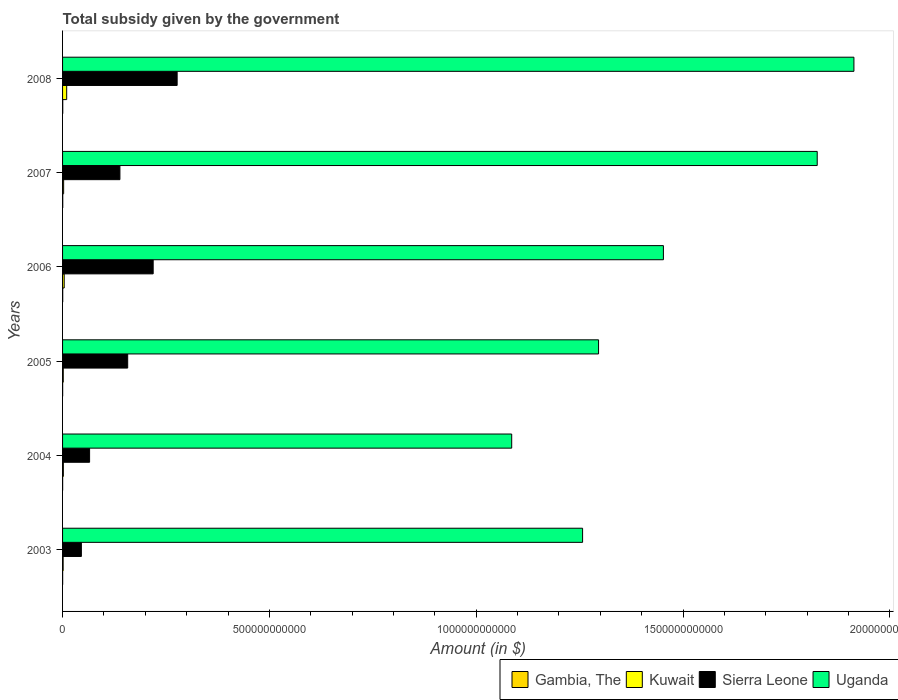How many different coloured bars are there?
Provide a short and direct response. 4. How many groups of bars are there?
Provide a short and direct response. 6. Are the number of bars on each tick of the Y-axis equal?
Keep it short and to the point. Yes. How many bars are there on the 1st tick from the bottom?
Provide a short and direct response. 4. What is the label of the 2nd group of bars from the top?
Offer a very short reply. 2007. What is the total revenue collected by the government in Uganda in 2007?
Keep it short and to the point. 1.82e+12. Across all years, what is the maximum total revenue collected by the government in Kuwait?
Provide a succinct answer. 9.98e+09. Across all years, what is the minimum total revenue collected by the government in Uganda?
Give a very brief answer. 1.09e+12. What is the total total revenue collected by the government in Gambia, The in the graph?
Your response must be concise. 1.90e+09. What is the difference between the total revenue collected by the government in Kuwait in 2005 and that in 2007?
Provide a succinct answer. -9.36e+08. What is the difference between the total revenue collected by the government in Kuwait in 2008 and the total revenue collected by the government in Sierra Leone in 2007?
Give a very brief answer. -1.29e+11. What is the average total revenue collected by the government in Kuwait per year?
Offer a terse response. 3.59e+09. In the year 2007, what is the difference between the total revenue collected by the government in Sierra Leone and total revenue collected by the government in Uganda?
Offer a terse response. -1.69e+12. What is the ratio of the total revenue collected by the government in Uganda in 2003 to that in 2007?
Offer a terse response. 0.69. What is the difference between the highest and the second highest total revenue collected by the government in Uganda?
Give a very brief answer. 8.87e+1. What is the difference between the highest and the lowest total revenue collected by the government in Sierra Leone?
Your answer should be compact. 2.32e+11. Is the sum of the total revenue collected by the government in Gambia, The in 2003 and 2007 greater than the maximum total revenue collected by the government in Sierra Leone across all years?
Provide a succinct answer. No. Is it the case that in every year, the sum of the total revenue collected by the government in Uganda and total revenue collected by the government in Gambia, The is greater than the sum of total revenue collected by the government in Sierra Leone and total revenue collected by the government in Kuwait?
Offer a terse response. No. What does the 4th bar from the top in 2008 represents?
Offer a very short reply. Gambia, The. What does the 3rd bar from the bottom in 2006 represents?
Offer a terse response. Sierra Leone. Is it the case that in every year, the sum of the total revenue collected by the government in Gambia, The and total revenue collected by the government in Kuwait is greater than the total revenue collected by the government in Uganda?
Your answer should be compact. No. How many bars are there?
Provide a short and direct response. 24. How many years are there in the graph?
Give a very brief answer. 6. What is the difference between two consecutive major ticks on the X-axis?
Ensure brevity in your answer.  5.00e+11. Are the values on the major ticks of X-axis written in scientific E-notation?
Your answer should be very brief. No. Does the graph contain any zero values?
Give a very brief answer. No. Does the graph contain grids?
Ensure brevity in your answer.  No. Where does the legend appear in the graph?
Ensure brevity in your answer.  Bottom right. How many legend labels are there?
Offer a terse response. 4. How are the legend labels stacked?
Your answer should be compact. Horizontal. What is the title of the graph?
Ensure brevity in your answer.  Total subsidy given by the government. Does "Greenland" appear as one of the legend labels in the graph?
Offer a very short reply. No. What is the label or title of the X-axis?
Make the answer very short. Amount (in $). What is the label or title of the Y-axis?
Your answer should be compact. Years. What is the Amount (in $) in Gambia, The in 2003?
Make the answer very short. 2.22e+08. What is the Amount (in $) of Kuwait in 2003?
Offer a very short reply. 1.40e+09. What is the Amount (in $) of Sierra Leone in 2003?
Make the answer very short. 4.55e+1. What is the Amount (in $) in Uganda in 2003?
Your response must be concise. 1.26e+12. What is the Amount (in $) of Gambia, The in 2004?
Provide a short and direct response. 1.91e+08. What is the Amount (in $) in Kuwait in 2004?
Give a very brief answer. 1.93e+09. What is the Amount (in $) of Sierra Leone in 2004?
Your answer should be compact. 6.53e+1. What is the Amount (in $) in Uganda in 2004?
Your answer should be very brief. 1.09e+12. What is the Amount (in $) in Gambia, The in 2005?
Offer a very short reply. 2.31e+08. What is the Amount (in $) in Kuwait in 2005?
Provide a short and direct response. 1.68e+09. What is the Amount (in $) in Sierra Leone in 2005?
Your answer should be compact. 1.57e+11. What is the Amount (in $) in Uganda in 2005?
Provide a succinct answer. 1.30e+12. What is the Amount (in $) of Gambia, The in 2006?
Offer a very short reply. 3.56e+08. What is the Amount (in $) of Kuwait in 2006?
Your answer should be compact. 3.94e+09. What is the Amount (in $) of Sierra Leone in 2006?
Offer a very short reply. 2.19e+11. What is the Amount (in $) of Uganda in 2006?
Your response must be concise. 1.45e+12. What is the Amount (in $) in Gambia, The in 2007?
Make the answer very short. 4.34e+08. What is the Amount (in $) in Kuwait in 2007?
Make the answer very short. 2.61e+09. What is the Amount (in $) in Sierra Leone in 2007?
Give a very brief answer. 1.39e+11. What is the Amount (in $) in Uganda in 2007?
Provide a succinct answer. 1.82e+12. What is the Amount (in $) in Gambia, The in 2008?
Provide a succinct answer. 4.63e+08. What is the Amount (in $) of Kuwait in 2008?
Provide a short and direct response. 9.98e+09. What is the Amount (in $) of Sierra Leone in 2008?
Your answer should be compact. 2.77e+11. What is the Amount (in $) in Uganda in 2008?
Ensure brevity in your answer.  1.91e+12. Across all years, what is the maximum Amount (in $) of Gambia, The?
Your answer should be very brief. 4.63e+08. Across all years, what is the maximum Amount (in $) in Kuwait?
Ensure brevity in your answer.  9.98e+09. Across all years, what is the maximum Amount (in $) in Sierra Leone?
Offer a terse response. 2.77e+11. Across all years, what is the maximum Amount (in $) in Uganda?
Your answer should be very brief. 1.91e+12. Across all years, what is the minimum Amount (in $) in Gambia, The?
Provide a succinct answer. 1.91e+08. Across all years, what is the minimum Amount (in $) in Kuwait?
Your answer should be compact. 1.40e+09. Across all years, what is the minimum Amount (in $) of Sierra Leone?
Provide a succinct answer. 4.55e+1. Across all years, what is the minimum Amount (in $) of Uganda?
Your answer should be compact. 1.09e+12. What is the total Amount (in $) in Gambia, The in the graph?
Provide a short and direct response. 1.90e+09. What is the total Amount (in $) of Kuwait in the graph?
Offer a terse response. 2.15e+1. What is the total Amount (in $) in Sierra Leone in the graph?
Offer a very short reply. 9.03e+11. What is the total Amount (in $) of Uganda in the graph?
Provide a succinct answer. 8.83e+12. What is the difference between the Amount (in $) in Gambia, The in 2003 and that in 2004?
Offer a very short reply. 3.08e+07. What is the difference between the Amount (in $) of Kuwait in 2003 and that in 2004?
Your answer should be very brief. -5.31e+08. What is the difference between the Amount (in $) of Sierra Leone in 2003 and that in 2004?
Provide a succinct answer. -1.98e+1. What is the difference between the Amount (in $) of Uganda in 2003 and that in 2004?
Keep it short and to the point. 1.71e+11. What is the difference between the Amount (in $) in Gambia, The in 2003 and that in 2005?
Provide a succinct answer. -9.00e+06. What is the difference between the Amount (in $) in Kuwait in 2003 and that in 2005?
Your response must be concise. -2.82e+08. What is the difference between the Amount (in $) in Sierra Leone in 2003 and that in 2005?
Your response must be concise. -1.12e+11. What is the difference between the Amount (in $) of Uganda in 2003 and that in 2005?
Ensure brevity in your answer.  -3.86e+1. What is the difference between the Amount (in $) of Gambia, The in 2003 and that in 2006?
Ensure brevity in your answer.  -1.34e+08. What is the difference between the Amount (in $) in Kuwait in 2003 and that in 2006?
Give a very brief answer. -2.54e+09. What is the difference between the Amount (in $) of Sierra Leone in 2003 and that in 2006?
Keep it short and to the point. -1.74e+11. What is the difference between the Amount (in $) in Uganda in 2003 and that in 2006?
Your answer should be compact. -1.95e+11. What is the difference between the Amount (in $) of Gambia, The in 2003 and that in 2007?
Ensure brevity in your answer.  -2.13e+08. What is the difference between the Amount (in $) of Kuwait in 2003 and that in 2007?
Make the answer very short. -1.22e+09. What is the difference between the Amount (in $) in Sierra Leone in 2003 and that in 2007?
Give a very brief answer. -9.32e+1. What is the difference between the Amount (in $) in Uganda in 2003 and that in 2007?
Make the answer very short. -5.67e+11. What is the difference between the Amount (in $) of Gambia, The in 2003 and that in 2008?
Your answer should be very brief. -2.42e+08. What is the difference between the Amount (in $) in Kuwait in 2003 and that in 2008?
Ensure brevity in your answer.  -8.58e+09. What is the difference between the Amount (in $) of Sierra Leone in 2003 and that in 2008?
Your answer should be very brief. -2.32e+11. What is the difference between the Amount (in $) in Uganda in 2003 and that in 2008?
Your response must be concise. -6.56e+11. What is the difference between the Amount (in $) in Gambia, The in 2004 and that in 2005?
Offer a terse response. -3.98e+07. What is the difference between the Amount (in $) in Kuwait in 2004 and that in 2005?
Your answer should be very brief. 2.49e+08. What is the difference between the Amount (in $) in Sierra Leone in 2004 and that in 2005?
Your response must be concise. -9.21e+1. What is the difference between the Amount (in $) in Uganda in 2004 and that in 2005?
Give a very brief answer. -2.10e+11. What is the difference between the Amount (in $) in Gambia, The in 2004 and that in 2006?
Give a very brief answer. -1.65e+08. What is the difference between the Amount (in $) in Kuwait in 2004 and that in 2006?
Give a very brief answer. -2.01e+09. What is the difference between the Amount (in $) of Sierra Leone in 2004 and that in 2006?
Your answer should be very brief. -1.54e+11. What is the difference between the Amount (in $) of Uganda in 2004 and that in 2006?
Keep it short and to the point. -3.67e+11. What is the difference between the Amount (in $) in Gambia, The in 2004 and that in 2007?
Provide a succinct answer. -2.44e+08. What is the difference between the Amount (in $) of Kuwait in 2004 and that in 2007?
Ensure brevity in your answer.  -6.87e+08. What is the difference between the Amount (in $) in Sierra Leone in 2004 and that in 2007?
Your answer should be compact. -7.33e+1. What is the difference between the Amount (in $) in Uganda in 2004 and that in 2007?
Your answer should be very brief. -7.39e+11. What is the difference between the Amount (in $) in Gambia, The in 2004 and that in 2008?
Offer a terse response. -2.72e+08. What is the difference between the Amount (in $) of Kuwait in 2004 and that in 2008?
Your answer should be very brief. -8.05e+09. What is the difference between the Amount (in $) in Sierra Leone in 2004 and that in 2008?
Your answer should be very brief. -2.12e+11. What is the difference between the Amount (in $) of Uganda in 2004 and that in 2008?
Your response must be concise. -8.27e+11. What is the difference between the Amount (in $) in Gambia, The in 2005 and that in 2006?
Give a very brief answer. -1.26e+08. What is the difference between the Amount (in $) of Kuwait in 2005 and that in 2006?
Give a very brief answer. -2.26e+09. What is the difference between the Amount (in $) in Sierra Leone in 2005 and that in 2006?
Offer a terse response. -6.16e+1. What is the difference between the Amount (in $) of Uganda in 2005 and that in 2006?
Provide a succinct answer. -1.57e+11. What is the difference between the Amount (in $) of Gambia, The in 2005 and that in 2007?
Your answer should be very brief. -2.04e+08. What is the difference between the Amount (in $) of Kuwait in 2005 and that in 2007?
Offer a very short reply. -9.36e+08. What is the difference between the Amount (in $) in Sierra Leone in 2005 and that in 2007?
Ensure brevity in your answer.  1.88e+1. What is the difference between the Amount (in $) of Uganda in 2005 and that in 2007?
Keep it short and to the point. -5.29e+11. What is the difference between the Amount (in $) of Gambia, The in 2005 and that in 2008?
Provide a succinct answer. -2.33e+08. What is the difference between the Amount (in $) in Kuwait in 2005 and that in 2008?
Offer a terse response. -8.30e+09. What is the difference between the Amount (in $) in Sierra Leone in 2005 and that in 2008?
Your response must be concise. -1.20e+11. What is the difference between the Amount (in $) of Uganda in 2005 and that in 2008?
Make the answer very short. -6.17e+11. What is the difference between the Amount (in $) in Gambia, The in 2006 and that in 2007?
Keep it short and to the point. -7.82e+07. What is the difference between the Amount (in $) in Kuwait in 2006 and that in 2007?
Provide a short and direct response. 1.33e+09. What is the difference between the Amount (in $) of Sierra Leone in 2006 and that in 2007?
Keep it short and to the point. 8.04e+1. What is the difference between the Amount (in $) in Uganda in 2006 and that in 2007?
Your answer should be compact. -3.72e+11. What is the difference between the Amount (in $) of Gambia, The in 2006 and that in 2008?
Your response must be concise. -1.07e+08. What is the difference between the Amount (in $) in Kuwait in 2006 and that in 2008?
Make the answer very short. -6.04e+09. What is the difference between the Amount (in $) of Sierra Leone in 2006 and that in 2008?
Give a very brief answer. -5.80e+1. What is the difference between the Amount (in $) in Uganda in 2006 and that in 2008?
Offer a terse response. -4.61e+11. What is the difference between the Amount (in $) in Gambia, The in 2007 and that in 2008?
Your response must be concise. -2.89e+07. What is the difference between the Amount (in $) of Kuwait in 2007 and that in 2008?
Your answer should be very brief. -7.36e+09. What is the difference between the Amount (in $) of Sierra Leone in 2007 and that in 2008?
Provide a short and direct response. -1.38e+11. What is the difference between the Amount (in $) of Uganda in 2007 and that in 2008?
Keep it short and to the point. -8.87e+1. What is the difference between the Amount (in $) in Gambia, The in 2003 and the Amount (in $) in Kuwait in 2004?
Give a very brief answer. -1.71e+09. What is the difference between the Amount (in $) of Gambia, The in 2003 and the Amount (in $) of Sierra Leone in 2004?
Offer a terse response. -6.51e+1. What is the difference between the Amount (in $) of Gambia, The in 2003 and the Amount (in $) of Uganda in 2004?
Give a very brief answer. -1.09e+12. What is the difference between the Amount (in $) of Kuwait in 2003 and the Amount (in $) of Sierra Leone in 2004?
Provide a short and direct response. -6.39e+1. What is the difference between the Amount (in $) in Kuwait in 2003 and the Amount (in $) in Uganda in 2004?
Your response must be concise. -1.08e+12. What is the difference between the Amount (in $) of Sierra Leone in 2003 and the Amount (in $) of Uganda in 2004?
Your answer should be very brief. -1.04e+12. What is the difference between the Amount (in $) in Gambia, The in 2003 and the Amount (in $) in Kuwait in 2005?
Make the answer very short. -1.46e+09. What is the difference between the Amount (in $) of Gambia, The in 2003 and the Amount (in $) of Sierra Leone in 2005?
Your response must be concise. -1.57e+11. What is the difference between the Amount (in $) of Gambia, The in 2003 and the Amount (in $) of Uganda in 2005?
Make the answer very short. -1.30e+12. What is the difference between the Amount (in $) of Kuwait in 2003 and the Amount (in $) of Sierra Leone in 2005?
Your answer should be very brief. -1.56e+11. What is the difference between the Amount (in $) in Kuwait in 2003 and the Amount (in $) in Uganda in 2005?
Provide a succinct answer. -1.29e+12. What is the difference between the Amount (in $) of Sierra Leone in 2003 and the Amount (in $) of Uganda in 2005?
Ensure brevity in your answer.  -1.25e+12. What is the difference between the Amount (in $) in Gambia, The in 2003 and the Amount (in $) in Kuwait in 2006?
Offer a very short reply. -3.72e+09. What is the difference between the Amount (in $) in Gambia, The in 2003 and the Amount (in $) in Sierra Leone in 2006?
Your response must be concise. -2.19e+11. What is the difference between the Amount (in $) in Gambia, The in 2003 and the Amount (in $) in Uganda in 2006?
Ensure brevity in your answer.  -1.45e+12. What is the difference between the Amount (in $) of Kuwait in 2003 and the Amount (in $) of Sierra Leone in 2006?
Ensure brevity in your answer.  -2.18e+11. What is the difference between the Amount (in $) of Kuwait in 2003 and the Amount (in $) of Uganda in 2006?
Offer a terse response. -1.45e+12. What is the difference between the Amount (in $) of Sierra Leone in 2003 and the Amount (in $) of Uganda in 2006?
Keep it short and to the point. -1.41e+12. What is the difference between the Amount (in $) of Gambia, The in 2003 and the Amount (in $) of Kuwait in 2007?
Offer a terse response. -2.39e+09. What is the difference between the Amount (in $) of Gambia, The in 2003 and the Amount (in $) of Sierra Leone in 2007?
Your answer should be very brief. -1.38e+11. What is the difference between the Amount (in $) of Gambia, The in 2003 and the Amount (in $) of Uganda in 2007?
Keep it short and to the point. -1.82e+12. What is the difference between the Amount (in $) in Kuwait in 2003 and the Amount (in $) in Sierra Leone in 2007?
Make the answer very short. -1.37e+11. What is the difference between the Amount (in $) in Kuwait in 2003 and the Amount (in $) in Uganda in 2007?
Provide a succinct answer. -1.82e+12. What is the difference between the Amount (in $) of Sierra Leone in 2003 and the Amount (in $) of Uganda in 2007?
Offer a terse response. -1.78e+12. What is the difference between the Amount (in $) of Gambia, The in 2003 and the Amount (in $) of Kuwait in 2008?
Provide a short and direct response. -9.76e+09. What is the difference between the Amount (in $) of Gambia, The in 2003 and the Amount (in $) of Sierra Leone in 2008?
Provide a succinct answer. -2.77e+11. What is the difference between the Amount (in $) in Gambia, The in 2003 and the Amount (in $) in Uganda in 2008?
Make the answer very short. -1.91e+12. What is the difference between the Amount (in $) in Kuwait in 2003 and the Amount (in $) in Sierra Leone in 2008?
Provide a short and direct response. -2.76e+11. What is the difference between the Amount (in $) of Kuwait in 2003 and the Amount (in $) of Uganda in 2008?
Offer a very short reply. -1.91e+12. What is the difference between the Amount (in $) in Sierra Leone in 2003 and the Amount (in $) in Uganda in 2008?
Ensure brevity in your answer.  -1.87e+12. What is the difference between the Amount (in $) of Gambia, The in 2004 and the Amount (in $) of Kuwait in 2005?
Provide a succinct answer. -1.49e+09. What is the difference between the Amount (in $) in Gambia, The in 2004 and the Amount (in $) in Sierra Leone in 2005?
Give a very brief answer. -1.57e+11. What is the difference between the Amount (in $) in Gambia, The in 2004 and the Amount (in $) in Uganda in 2005?
Make the answer very short. -1.30e+12. What is the difference between the Amount (in $) in Kuwait in 2004 and the Amount (in $) in Sierra Leone in 2005?
Give a very brief answer. -1.55e+11. What is the difference between the Amount (in $) in Kuwait in 2004 and the Amount (in $) in Uganda in 2005?
Offer a terse response. -1.29e+12. What is the difference between the Amount (in $) of Sierra Leone in 2004 and the Amount (in $) of Uganda in 2005?
Keep it short and to the point. -1.23e+12. What is the difference between the Amount (in $) of Gambia, The in 2004 and the Amount (in $) of Kuwait in 2006?
Provide a short and direct response. -3.75e+09. What is the difference between the Amount (in $) in Gambia, The in 2004 and the Amount (in $) in Sierra Leone in 2006?
Your answer should be compact. -2.19e+11. What is the difference between the Amount (in $) of Gambia, The in 2004 and the Amount (in $) of Uganda in 2006?
Your answer should be very brief. -1.45e+12. What is the difference between the Amount (in $) of Kuwait in 2004 and the Amount (in $) of Sierra Leone in 2006?
Provide a short and direct response. -2.17e+11. What is the difference between the Amount (in $) of Kuwait in 2004 and the Amount (in $) of Uganda in 2006?
Your answer should be very brief. -1.45e+12. What is the difference between the Amount (in $) of Sierra Leone in 2004 and the Amount (in $) of Uganda in 2006?
Provide a succinct answer. -1.39e+12. What is the difference between the Amount (in $) of Gambia, The in 2004 and the Amount (in $) of Kuwait in 2007?
Ensure brevity in your answer.  -2.42e+09. What is the difference between the Amount (in $) in Gambia, The in 2004 and the Amount (in $) in Sierra Leone in 2007?
Make the answer very short. -1.38e+11. What is the difference between the Amount (in $) of Gambia, The in 2004 and the Amount (in $) of Uganda in 2007?
Give a very brief answer. -1.82e+12. What is the difference between the Amount (in $) in Kuwait in 2004 and the Amount (in $) in Sierra Leone in 2007?
Keep it short and to the point. -1.37e+11. What is the difference between the Amount (in $) of Kuwait in 2004 and the Amount (in $) of Uganda in 2007?
Ensure brevity in your answer.  -1.82e+12. What is the difference between the Amount (in $) in Sierra Leone in 2004 and the Amount (in $) in Uganda in 2007?
Provide a succinct answer. -1.76e+12. What is the difference between the Amount (in $) in Gambia, The in 2004 and the Amount (in $) in Kuwait in 2008?
Provide a succinct answer. -9.79e+09. What is the difference between the Amount (in $) of Gambia, The in 2004 and the Amount (in $) of Sierra Leone in 2008?
Keep it short and to the point. -2.77e+11. What is the difference between the Amount (in $) in Gambia, The in 2004 and the Amount (in $) in Uganda in 2008?
Your answer should be compact. -1.91e+12. What is the difference between the Amount (in $) of Kuwait in 2004 and the Amount (in $) of Sierra Leone in 2008?
Keep it short and to the point. -2.75e+11. What is the difference between the Amount (in $) of Kuwait in 2004 and the Amount (in $) of Uganda in 2008?
Ensure brevity in your answer.  -1.91e+12. What is the difference between the Amount (in $) of Sierra Leone in 2004 and the Amount (in $) of Uganda in 2008?
Your answer should be compact. -1.85e+12. What is the difference between the Amount (in $) of Gambia, The in 2005 and the Amount (in $) of Kuwait in 2006?
Give a very brief answer. -3.71e+09. What is the difference between the Amount (in $) of Gambia, The in 2005 and the Amount (in $) of Sierra Leone in 2006?
Ensure brevity in your answer.  -2.19e+11. What is the difference between the Amount (in $) in Gambia, The in 2005 and the Amount (in $) in Uganda in 2006?
Give a very brief answer. -1.45e+12. What is the difference between the Amount (in $) of Kuwait in 2005 and the Amount (in $) of Sierra Leone in 2006?
Your answer should be compact. -2.17e+11. What is the difference between the Amount (in $) in Kuwait in 2005 and the Amount (in $) in Uganda in 2006?
Your response must be concise. -1.45e+12. What is the difference between the Amount (in $) of Sierra Leone in 2005 and the Amount (in $) of Uganda in 2006?
Your response must be concise. -1.30e+12. What is the difference between the Amount (in $) of Gambia, The in 2005 and the Amount (in $) of Kuwait in 2007?
Ensure brevity in your answer.  -2.38e+09. What is the difference between the Amount (in $) of Gambia, The in 2005 and the Amount (in $) of Sierra Leone in 2007?
Your answer should be very brief. -1.38e+11. What is the difference between the Amount (in $) of Gambia, The in 2005 and the Amount (in $) of Uganda in 2007?
Provide a succinct answer. -1.82e+12. What is the difference between the Amount (in $) in Kuwait in 2005 and the Amount (in $) in Sierra Leone in 2007?
Give a very brief answer. -1.37e+11. What is the difference between the Amount (in $) in Kuwait in 2005 and the Amount (in $) in Uganda in 2007?
Your response must be concise. -1.82e+12. What is the difference between the Amount (in $) of Sierra Leone in 2005 and the Amount (in $) of Uganda in 2007?
Your answer should be very brief. -1.67e+12. What is the difference between the Amount (in $) of Gambia, The in 2005 and the Amount (in $) of Kuwait in 2008?
Offer a very short reply. -9.75e+09. What is the difference between the Amount (in $) in Gambia, The in 2005 and the Amount (in $) in Sierra Leone in 2008?
Your response must be concise. -2.77e+11. What is the difference between the Amount (in $) of Gambia, The in 2005 and the Amount (in $) of Uganda in 2008?
Keep it short and to the point. -1.91e+12. What is the difference between the Amount (in $) of Kuwait in 2005 and the Amount (in $) of Sierra Leone in 2008?
Offer a very short reply. -2.75e+11. What is the difference between the Amount (in $) of Kuwait in 2005 and the Amount (in $) of Uganda in 2008?
Give a very brief answer. -1.91e+12. What is the difference between the Amount (in $) in Sierra Leone in 2005 and the Amount (in $) in Uganda in 2008?
Give a very brief answer. -1.76e+12. What is the difference between the Amount (in $) in Gambia, The in 2006 and the Amount (in $) in Kuwait in 2007?
Keep it short and to the point. -2.26e+09. What is the difference between the Amount (in $) of Gambia, The in 2006 and the Amount (in $) of Sierra Leone in 2007?
Offer a very short reply. -1.38e+11. What is the difference between the Amount (in $) in Gambia, The in 2006 and the Amount (in $) in Uganda in 2007?
Your response must be concise. -1.82e+12. What is the difference between the Amount (in $) of Kuwait in 2006 and the Amount (in $) of Sierra Leone in 2007?
Your answer should be very brief. -1.35e+11. What is the difference between the Amount (in $) of Kuwait in 2006 and the Amount (in $) of Uganda in 2007?
Make the answer very short. -1.82e+12. What is the difference between the Amount (in $) in Sierra Leone in 2006 and the Amount (in $) in Uganda in 2007?
Provide a succinct answer. -1.61e+12. What is the difference between the Amount (in $) in Gambia, The in 2006 and the Amount (in $) in Kuwait in 2008?
Ensure brevity in your answer.  -9.62e+09. What is the difference between the Amount (in $) in Gambia, The in 2006 and the Amount (in $) in Sierra Leone in 2008?
Provide a succinct answer. -2.77e+11. What is the difference between the Amount (in $) in Gambia, The in 2006 and the Amount (in $) in Uganda in 2008?
Offer a very short reply. -1.91e+12. What is the difference between the Amount (in $) in Kuwait in 2006 and the Amount (in $) in Sierra Leone in 2008?
Ensure brevity in your answer.  -2.73e+11. What is the difference between the Amount (in $) in Kuwait in 2006 and the Amount (in $) in Uganda in 2008?
Make the answer very short. -1.91e+12. What is the difference between the Amount (in $) in Sierra Leone in 2006 and the Amount (in $) in Uganda in 2008?
Keep it short and to the point. -1.69e+12. What is the difference between the Amount (in $) in Gambia, The in 2007 and the Amount (in $) in Kuwait in 2008?
Keep it short and to the point. -9.54e+09. What is the difference between the Amount (in $) in Gambia, The in 2007 and the Amount (in $) in Sierra Leone in 2008?
Your response must be concise. -2.77e+11. What is the difference between the Amount (in $) of Gambia, The in 2007 and the Amount (in $) of Uganda in 2008?
Offer a very short reply. -1.91e+12. What is the difference between the Amount (in $) in Kuwait in 2007 and the Amount (in $) in Sierra Leone in 2008?
Give a very brief answer. -2.74e+11. What is the difference between the Amount (in $) of Kuwait in 2007 and the Amount (in $) of Uganda in 2008?
Your answer should be very brief. -1.91e+12. What is the difference between the Amount (in $) in Sierra Leone in 2007 and the Amount (in $) in Uganda in 2008?
Provide a short and direct response. -1.77e+12. What is the average Amount (in $) of Gambia, The per year?
Make the answer very short. 3.16e+08. What is the average Amount (in $) in Kuwait per year?
Keep it short and to the point. 3.59e+09. What is the average Amount (in $) of Sierra Leone per year?
Provide a succinct answer. 1.50e+11. What is the average Amount (in $) of Uganda per year?
Offer a very short reply. 1.47e+12. In the year 2003, what is the difference between the Amount (in $) in Gambia, The and Amount (in $) in Kuwait?
Give a very brief answer. -1.17e+09. In the year 2003, what is the difference between the Amount (in $) in Gambia, The and Amount (in $) in Sierra Leone?
Keep it short and to the point. -4.53e+1. In the year 2003, what is the difference between the Amount (in $) of Gambia, The and Amount (in $) of Uganda?
Keep it short and to the point. -1.26e+12. In the year 2003, what is the difference between the Amount (in $) in Kuwait and Amount (in $) in Sierra Leone?
Provide a succinct answer. -4.41e+1. In the year 2003, what is the difference between the Amount (in $) in Kuwait and Amount (in $) in Uganda?
Provide a succinct answer. -1.26e+12. In the year 2003, what is the difference between the Amount (in $) in Sierra Leone and Amount (in $) in Uganda?
Ensure brevity in your answer.  -1.21e+12. In the year 2004, what is the difference between the Amount (in $) in Gambia, The and Amount (in $) in Kuwait?
Your response must be concise. -1.74e+09. In the year 2004, what is the difference between the Amount (in $) of Gambia, The and Amount (in $) of Sierra Leone?
Give a very brief answer. -6.51e+1. In the year 2004, what is the difference between the Amount (in $) of Gambia, The and Amount (in $) of Uganda?
Give a very brief answer. -1.09e+12. In the year 2004, what is the difference between the Amount (in $) in Kuwait and Amount (in $) in Sierra Leone?
Keep it short and to the point. -6.34e+1. In the year 2004, what is the difference between the Amount (in $) of Kuwait and Amount (in $) of Uganda?
Make the answer very short. -1.08e+12. In the year 2004, what is the difference between the Amount (in $) in Sierra Leone and Amount (in $) in Uganda?
Offer a terse response. -1.02e+12. In the year 2005, what is the difference between the Amount (in $) in Gambia, The and Amount (in $) in Kuwait?
Your answer should be compact. -1.45e+09. In the year 2005, what is the difference between the Amount (in $) of Gambia, The and Amount (in $) of Sierra Leone?
Give a very brief answer. -1.57e+11. In the year 2005, what is the difference between the Amount (in $) in Gambia, The and Amount (in $) in Uganda?
Offer a terse response. -1.30e+12. In the year 2005, what is the difference between the Amount (in $) in Kuwait and Amount (in $) in Sierra Leone?
Offer a very short reply. -1.56e+11. In the year 2005, what is the difference between the Amount (in $) in Kuwait and Amount (in $) in Uganda?
Your response must be concise. -1.29e+12. In the year 2005, what is the difference between the Amount (in $) in Sierra Leone and Amount (in $) in Uganda?
Make the answer very short. -1.14e+12. In the year 2006, what is the difference between the Amount (in $) in Gambia, The and Amount (in $) in Kuwait?
Give a very brief answer. -3.58e+09. In the year 2006, what is the difference between the Amount (in $) in Gambia, The and Amount (in $) in Sierra Leone?
Your answer should be very brief. -2.19e+11. In the year 2006, what is the difference between the Amount (in $) in Gambia, The and Amount (in $) in Uganda?
Ensure brevity in your answer.  -1.45e+12. In the year 2006, what is the difference between the Amount (in $) of Kuwait and Amount (in $) of Sierra Leone?
Ensure brevity in your answer.  -2.15e+11. In the year 2006, what is the difference between the Amount (in $) of Kuwait and Amount (in $) of Uganda?
Offer a very short reply. -1.45e+12. In the year 2006, what is the difference between the Amount (in $) in Sierra Leone and Amount (in $) in Uganda?
Make the answer very short. -1.23e+12. In the year 2007, what is the difference between the Amount (in $) in Gambia, The and Amount (in $) in Kuwait?
Make the answer very short. -2.18e+09. In the year 2007, what is the difference between the Amount (in $) in Gambia, The and Amount (in $) in Sierra Leone?
Your answer should be very brief. -1.38e+11. In the year 2007, what is the difference between the Amount (in $) in Gambia, The and Amount (in $) in Uganda?
Offer a terse response. -1.82e+12. In the year 2007, what is the difference between the Amount (in $) in Kuwait and Amount (in $) in Sierra Leone?
Ensure brevity in your answer.  -1.36e+11. In the year 2007, what is the difference between the Amount (in $) of Kuwait and Amount (in $) of Uganda?
Your response must be concise. -1.82e+12. In the year 2007, what is the difference between the Amount (in $) of Sierra Leone and Amount (in $) of Uganda?
Offer a terse response. -1.69e+12. In the year 2008, what is the difference between the Amount (in $) in Gambia, The and Amount (in $) in Kuwait?
Offer a terse response. -9.52e+09. In the year 2008, what is the difference between the Amount (in $) of Gambia, The and Amount (in $) of Sierra Leone?
Ensure brevity in your answer.  -2.77e+11. In the year 2008, what is the difference between the Amount (in $) of Gambia, The and Amount (in $) of Uganda?
Your response must be concise. -1.91e+12. In the year 2008, what is the difference between the Amount (in $) in Kuwait and Amount (in $) in Sierra Leone?
Ensure brevity in your answer.  -2.67e+11. In the year 2008, what is the difference between the Amount (in $) of Kuwait and Amount (in $) of Uganda?
Your answer should be compact. -1.90e+12. In the year 2008, what is the difference between the Amount (in $) of Sierra Leone and Amount (in $) of Uganda?
Your answer should be very brief. -1.64e+12. What is the ratio of the Amount (in $) in Gambia, The in 2003 to that in 2004?
Offer a terse response. 1.16. What is the ratio of the Amount (in $) of Kuwait in 2003 to that in 2004?
Keep it short and to the point. 0.72. What is the ratio of the Amount (in $) in Sierra Leone in 2003 to that in 2004?
Offer a very short reply. 0.7. What is the ratio of the Amount (in $) in Uganda in 2003 to that in 2004?
Your answer should be compact. 1.16. What is the ratio of the Amount (in $) of Gambia, The in 2003 to that in 2005?
Keep it short and to the point. 0.96. What is the ratio of the Amount (in $) in Kuwait in 2003 to that in 2005?
Make the answer very short. 0.83. What is the ratio of the Amount (in $) of Sierra Leone in 2003 to that in 2005?
Offer a terse response. 0.29. What is the ratio of the Amount (in $) of Uganda in 2003 to that in 2005?
Give a very brief answer. 0.97. What is the ratio of the Amount (in $) in Gambia, The in 2003 to that in 2006?
Keep it short and to the point. 0.62. What is the ratio of the Amount (in $) of Kuwait in 2003 to that in 2006?
Keep it short and to the point. 0.35. What is the ratio of the Amount (in $) in Sierra Leone in 2003 to that in 2006?
Your response must be concise. 0.21. What is the ratio of the Amount (in $) in Uganda in 2003 to that in 2006?
Make the answer very short. 0.87. What is the ratio of the Amount (in $) of Gambia, The in 2003 to that in 2007?
Your answer should be very brief. 0.51. What is the ratio of the Amount (in $) in Kuwait in 2003 to that in 2007?
Your answer should be compact. 0.53. What is the ratio of the Amount (in $) of Sierra Leone in 2003 to that in 2007?
Your answer should be compact. 0.33. What is the ratio of the Amount (in $) of Uganda in 2003 to that in 2007?
Provide a succinct answer. 0.69. What is the ratio of the Amount (in $) of Gambia, The in 2003 to that in 2008?
Ensure brevity in your answer.  0.48. What is the ratio of the Amount (in $) in Kuwait in 2003 to that in 2008?
Provide a short and direct response. 0.14. What is the ratio of the Amount (in $) in Sierra Leone in 2003 to that in 2008?
Make the answer very short. 0.16. What is the ratio of the Amount (in $) in Uganda in 2003 to that in 2008?
Make the answer very short. 0.66. What is the ratio of the Amount (in $) of Gambia, The in 2004 to that in 2005?
Offer a terse response. 0.83. What is the ratio of the Amount (in $) of Kuwait in 2004 to that in 2005?
Provide a succinct answer. 1.15. What is the ratio of the Amount (in $) of Sierra Leone in 2004 to that in 2005?
Your response must be concise. 0.41. What is the ratio of the Amount (in $) in Uganda in 2004 to that in 2005?
Make the answer very short. 0.84. What is the ratio of the Amount (in $) in Gambia, The in 2004 to that in 2006?
Give a very brief answer. 0.54. What is the ratio of the Amount (in $) in Kuwait in 2004 to that in 2006?
Your response must be concise. 0.49. What is the ratio of the Amount (in $) in Sierra Leone in 2004 to that in 2006?
Provide a short and direct response. 0.3. What is the ratio of the Amount (in $) of Uganda in 2004 to that in 2006?
Give a very brief answer. 0.75. What is the ratio of the Amount (in $) in Gambia, The in 2004 to that in 2007?
Make the answer very short. 0.44. What is the ratio of the Amount (in $) in Kuwait in 2004 to that in 2007?
Offer a terse response. 0.74. What is the ratio of the Amount (in $) in Sierra Leone in 2004 to that in 2007?
Offer a terse response. 0.47. What is the ratio of the Amount (in $) in Uganda in 2004 to that in 2007?
Ensure brevity in your answer.  0.6. What is the ratio of the Amount (in $) of Gambia, The in 2004 to that in 2008?
Give a very brief answer. 0.41. What is the ratio of the Amount (in $) in Kuwait in 2004 to that in 2008?
Your response must be concise. 0.19. What is the ratio of the Amount (in $) of Sierra Leone in 2004 to that in 2008?
Your response must be concise. 0.24. What is the ratio of the Amount (in $) of Uganda in 2004 to that in 2008?
Provide a succinct answer. 0.57. What is the ratio of the Amount (in $) in Gambia, The in 2005 to that in 2006?
Your answer should be compact. 0.65. What is the ratio of the Amount (in $) of Kuwait in 2005 to that in 2006?
Your answer should be very brief. 0.43. What is the ratio of the Amount (in $) of Sierra Leone in 2005 to that in 2006?
Ensure brevity in your answer.  0.72. What is the ratio of the Amount (in $) of Uganda in 2005 to that in 2006?
Your answer should be very brief. 0.89. What is the ratio of the Amount (in $) of Gambia, The in 2005 to that in 2007?
Offer a terse response. 0.53. What is the ratio of the Amount (in $) in Kuwait in 2005 to that in 2007?
Ensure brevity in your answer.  0.64. What is the ratio of the Amount (in $) in Sierra Leone in 2005 to that in 2007?
Give a very brief answer. 1.14. What is the ratio of the Amount (in $) of Uganda in 2005 to that in 2007?
Offer a terse response. 0.71. What is the ratio of the Amount (in $) in Gambia, The in 2005 to that in 2008?
Your answer should be very brief. 0.5. What is the ratio of the Amount (in $) in Kuwait in 2005 to that in 2008?
Provide a short and direct response. 0.17. What is the ratio of the Amount (in $) in Sierra Leone in 2005 to that in 2008?
Your answer should be very brief. 0.57. What is the ratio of the Amount (in $) in Uganda in 2005 to that in 2008?
Provide a succinct answer. 0.68. What is the ratio of the Amount (in $) in Gambia, The in 2006 to that in 2007?
Keep it short and to the point. 0.82. What is the ratio of the Amount (in $) of Kuwait in 2006 to that in 2007?
Give a very brief answer. 1.51. What is the ratio of the Amount (in $) in Sierra Leone in 2006 to that in 2007?
Your answer should be compact. 1.58. What is the ratio of the Amount (in $) of Uganda in 2006 to that in 2007?
Give a very brief answer. 0.8. What is the ratio of the Amount (in $) in Gambia, The in 2006 to that in 2008?
Offer a very short reply. 0.77. What is the ratio of the Amount (in $) of Kuwait in 2006 to that in 2008?
Your answer should be very brief. 0.39. What is the ratio of the Amount (in $) of Sierra Leone in 2006 to that in 2008?
Give a very brief answer. 0.79. What is the ratio of the Amount (in $) of Uganda in 2006 to that in 2008?
Provide a short and direct response. 0.76. What is the ratio of the Amount (in $) in Gambia, The in 2007 to that in 2008?
Make the answer very short. 0.94. What is the ratio of the Amount (in $) in Kuwait in 2007 to that in 2008?
Offer a very short reply. 0.26. What is the ratio of the Amount (in $) of Sierra Leone in 2007 to that in 2008?
Ensure brevity in your answer.  0.5. What is the ratio of the Amount (in $) of Uganda in 2007 to that in 2008?
Offer a very short reply. 0.95. What is the difference between the highest and the second highest Amount (in $) in Gambia, The?
Provide a short and direct response. 2.89e+07. What is the difference between the highest and the second highest Amount (in $) of Kuwait?
Your response must be concise. 6.04e+09. What is the difference between the highest and the second highest Amount (in $) of Sierra Leone?
Your answer should be very brief. 5.80e+1. What is the difference between the highest and the second highest Amount (in $) of Uganda?
Your response must be concise. 8.87e+1. What is the difference between the highest and the lowest Amount (in $) in Gambia, The?
Your response must be concise. 2.72e+08. What is the difference between the highest and the lowest Amount (in $) in Kuwait?
Provide a short and direct response. 8.58e+09. What is the difference between the highest and the lowest Amount (in $) of Sierra Leone?
Your answer should be very brief. 2.32e+11. What is the difference between the highest and the lowest Amount (in $) in Uganda?
Provide a succinct answer. 8.27e+11. 